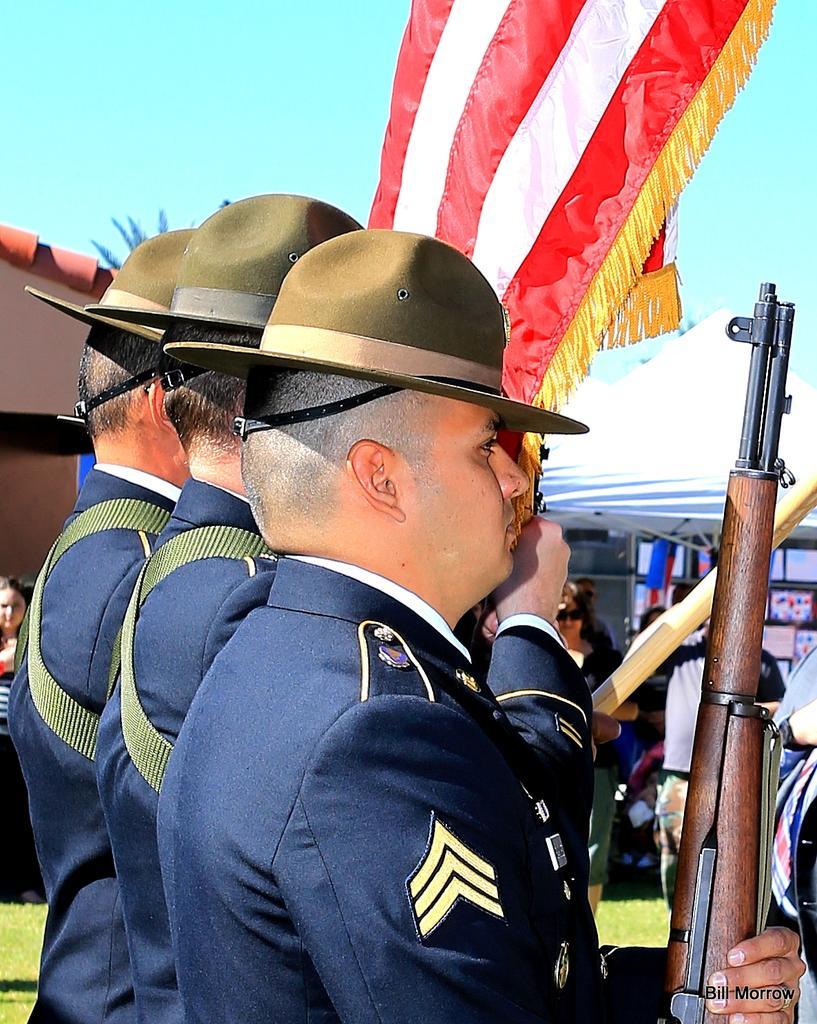How would you summarize this image in a sentence or two? In the foreground of this image, there are three men standing. One is holding a gun and another is holding a flag. In the background, it seems like there is a tent and persons under it. On the left, there is a woman standing on the grass. At the top, there is the sky. 